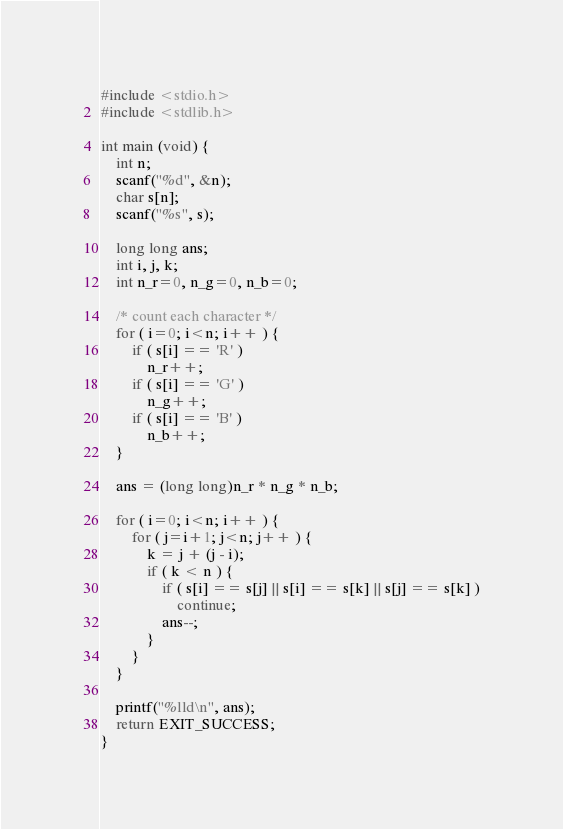Convert code to text. <code><loc_0><loc_0><loc_500><loc_500><_C_>#include <stdio.h>
#include <stdlib.h>

int main (void) {
    int n;
    scanf("%d", &n);
    char s[n];
    scanf("%s", s);

    long long ans;
    int i, j, k;
    int n_r=0, n_g=0, n_b=0;

    /* count each character */
    for ( i=0; i<n; i++ ) {
        if ( s[i] == 'R' )
            n_r++;
        if ( s[i] == 'G' )
            n_g++;
        if ( s[i] == 'B' )
            n_b++;
    }

    ans = (long long)n_r * n_g * n_b;

    for ( i=0; i<n; i++ ) {
        for ( j=i+1; j<n; j++ ) {
            k = j + (j - i);
            if ( k < n ) {
                if ( s[i] == s[j] || s[i] == s[k] || s[j] == s[k] )
                    continue;
                ans--;
            }
        }
    }

    printf("%lld\n", ans);
    return EXIT_SUCCESS;
}
</code> 